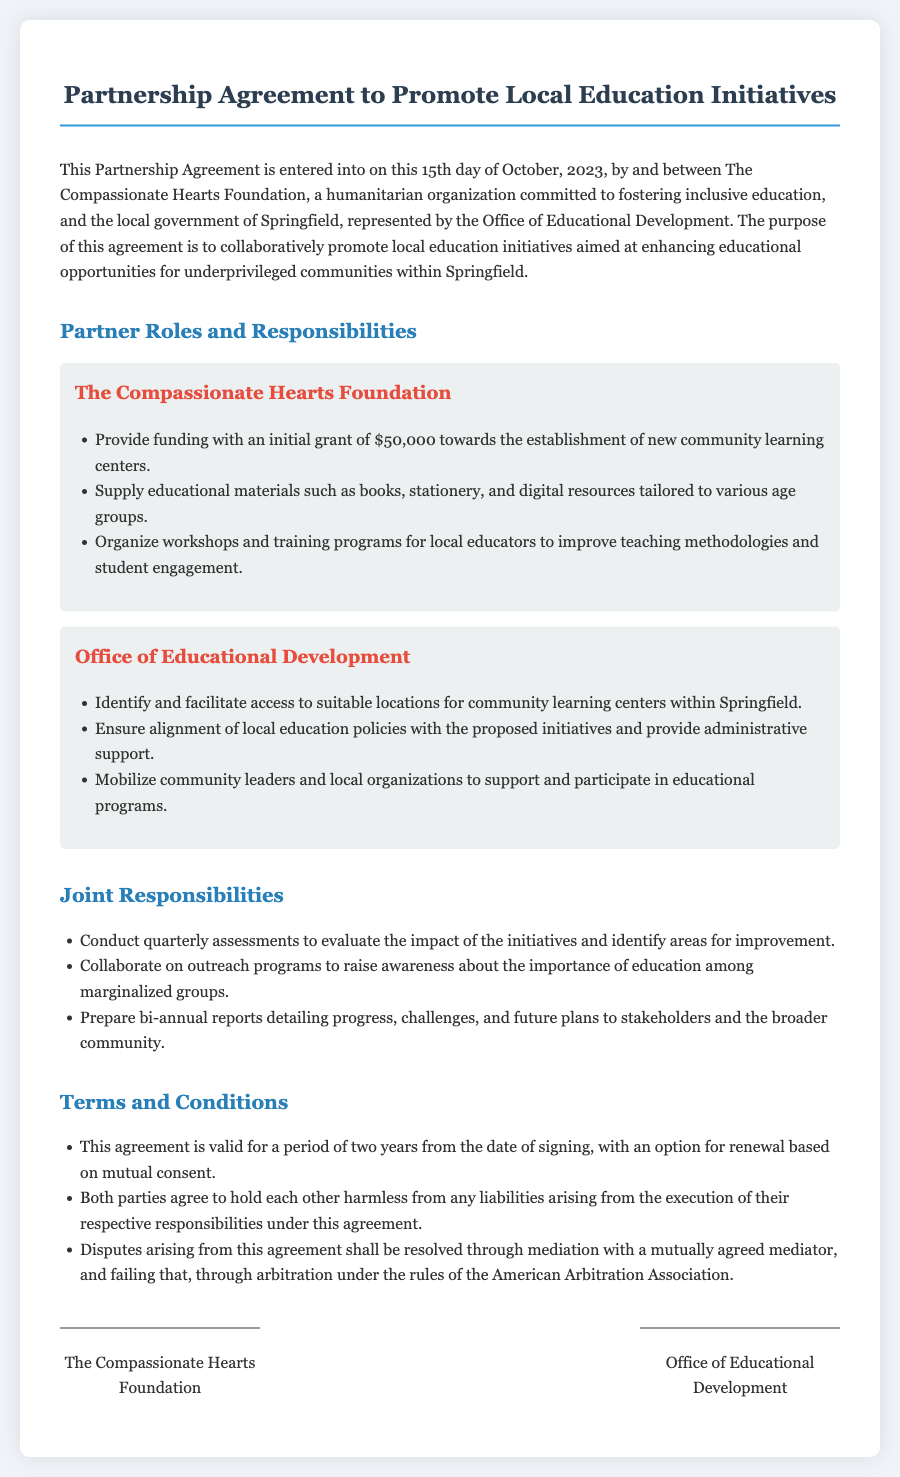What is the date of the agreement? The agreement states it was entered into on October 15, 2023.
Answer: October 15, 2023 Who represents the local government in this partnership? The document specifies that the local government is represented by the Office of Educational Development.
Answer: Office of Educational Development What is the initial grant amount provided by The Compassionate Hearts Foundation? The foundation commits an initial grant of $50,000 towards establishing new community learning centers.
Answer: $50,000 How long is the agreement valid? The document mentions that the agreement is valid for a period of two years from the signing date.
Answer: Two years What is one joint responsibility agreed upon by both parties? One of the joint responsibilities includes conducting quarterly assessments to evaluate the impact of the initiatives.
Answer: Quarterly assessments What is the purpose of the partnership? The purpose outlined in the agreement is to collaboratively promote local education initiatives.
Answer: Collaboratively promote local education initiatives What type of support will the Office of Educational Development provide? The office will provide administrative support and ensure alignment with local education policies.
Answer: Administrative support What happens if disputes arise from this agreement? The document states that disputes will be resolved through mediation and, if necessary, arbitration.
Answer: Mediation and arbitration 